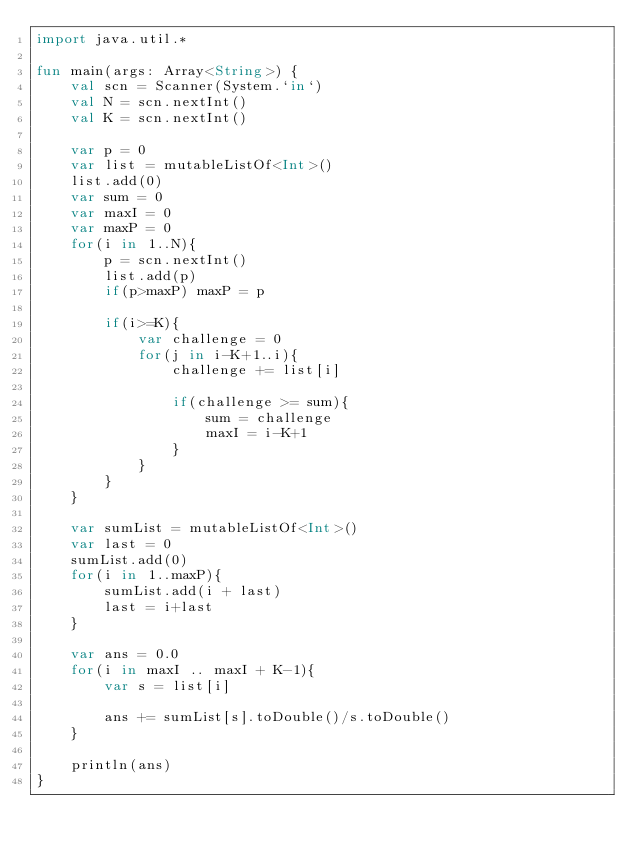<code> <loc_0><loc_0><loc_500><loc_500><_Kotlin_>import java.util.*

fun main(args: Array<String>) {
    val scn = Scanner(System.`in`)
    val N = scn.nextInt()
    val K = scn.nextInt()

    var p = 0
    var list = mutableListOf<Int>()
    list.add(0)
    var sum = 0
    var maxI = 0
    var maxP = 0
    for(i in 1..N){
        p = scn.nextInt()
        list.add(p)
        if(p>maxP) maxP = p

        if(i>=K){
            var challenge = 0
            for(j in i-K+1..i){
                challenge += list[i]

                if(challenge >= sum){
                    sum = challenge
                    maxI = i-K+1
                }
            }
        }
    }

    var sumList = mutableListOf<Int>()
    var last = 0
    sumList.add(0)
    for(i in 1..maxP){
        sumList.add(i + last)
        last = i+last
    }

    var ans = 0.0
    for(i in maxI .. maxI + K-1){
        var s = list[i]

        ans += sumList[s].toDouble()/s.toDouble()
    }

    println(ans)
}</code> 